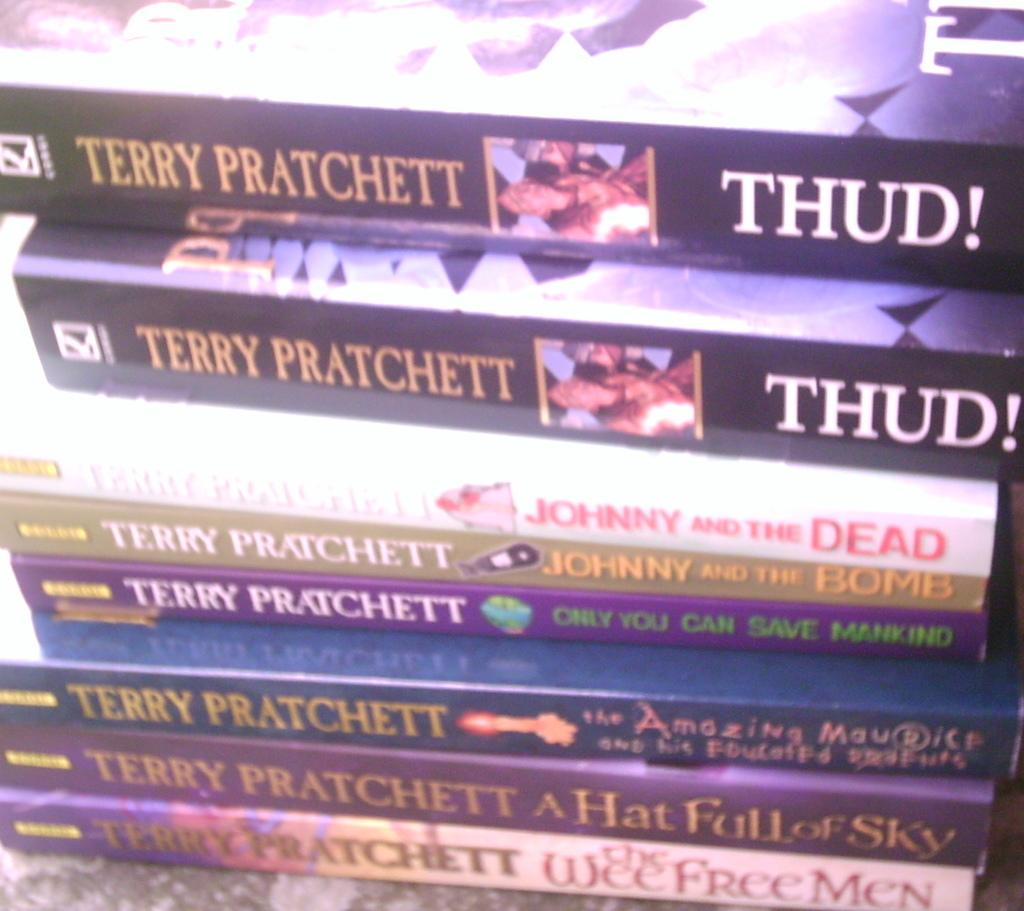<image>
Describe the image concisely. Eight paperback books, all by author Terry Pratchett, are stacked on top of each other.. 